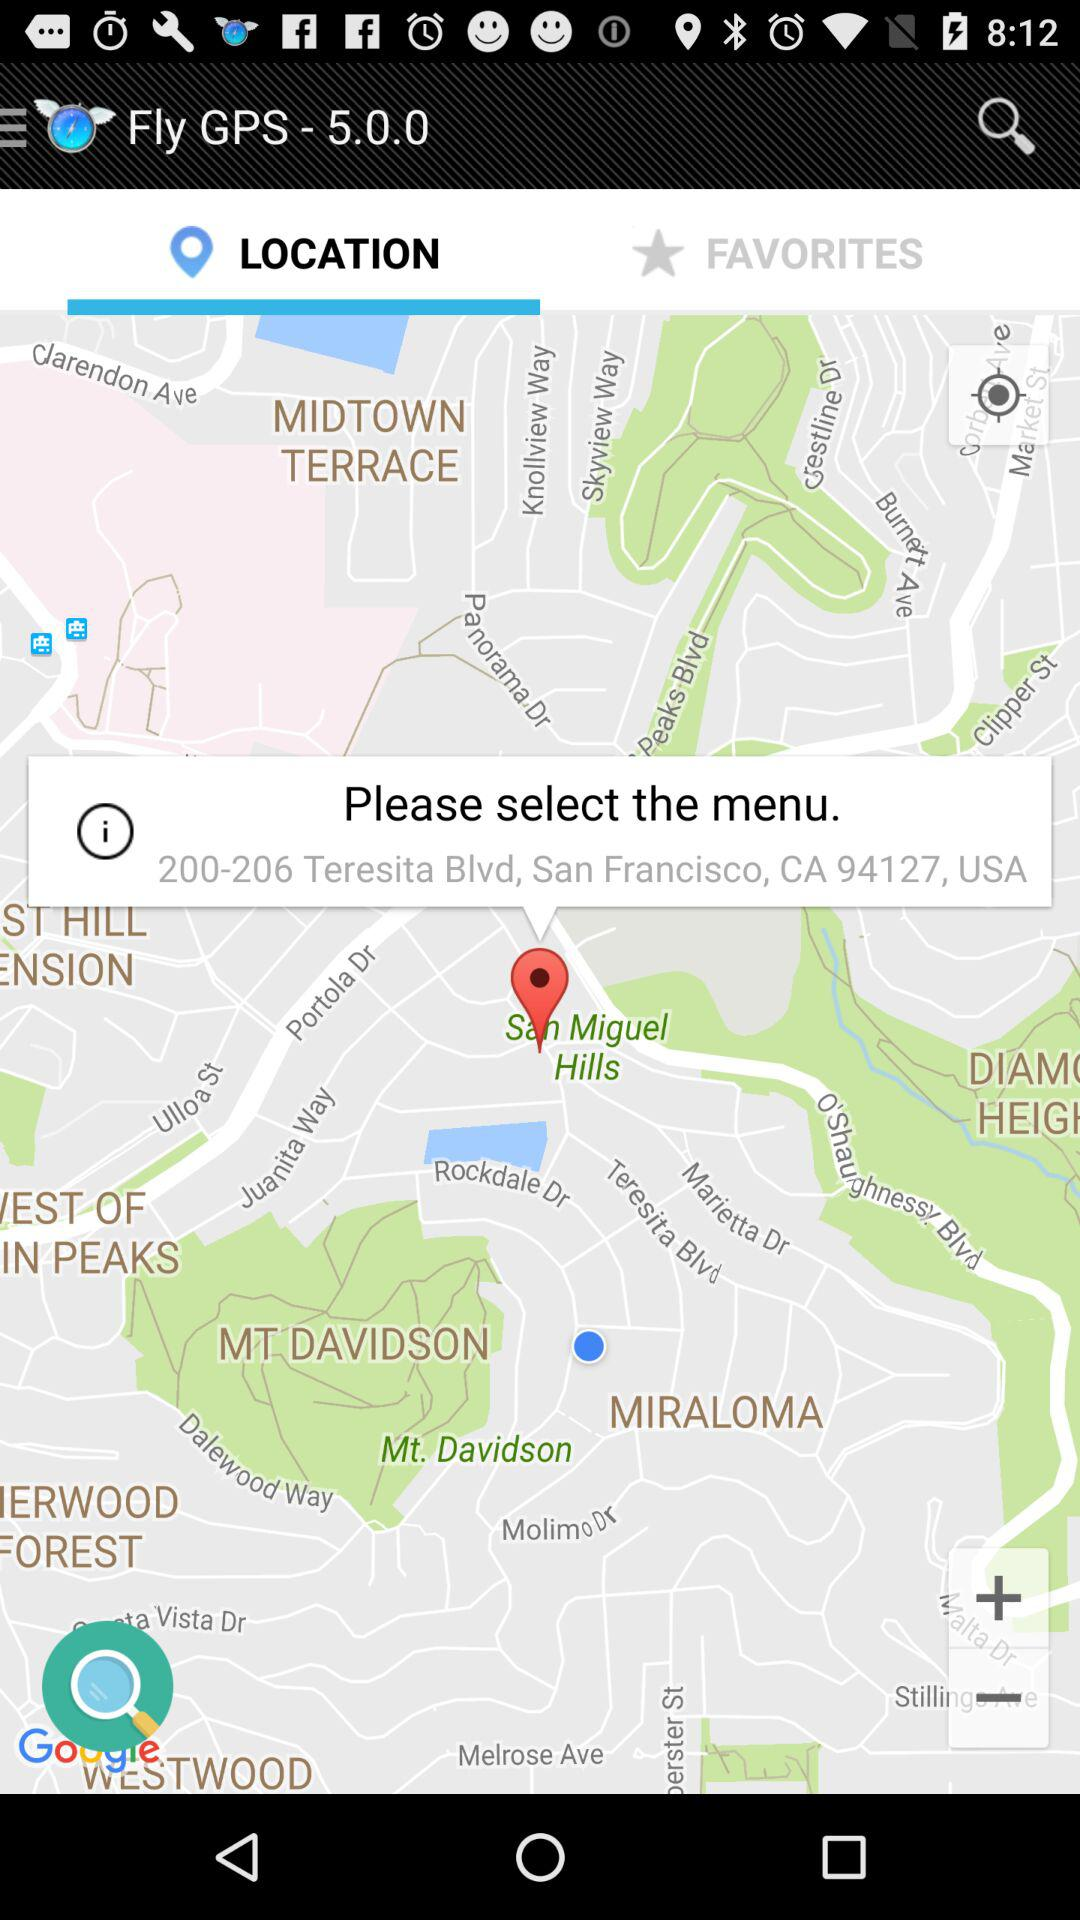What is the current location? The current location is 200-206 Teresita Blvd, San Francisco, CA 94127, USA. 